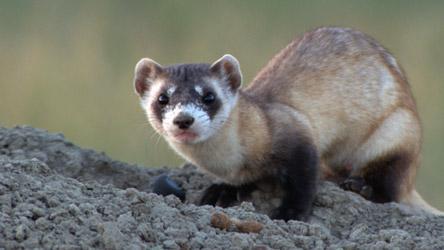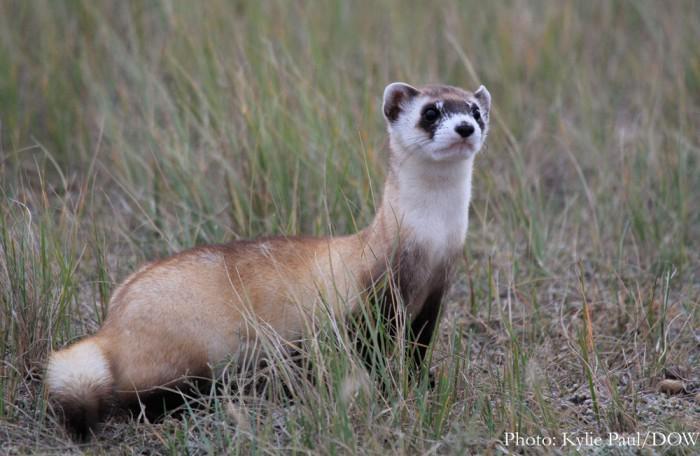The first image is the image on the left, the second image is the image on the right. For the images displayed, is the sentence "There are exactly two ferrets." factually correct? Answer yes or no. Yes. The first image is the image on the left, the second image is the image on the right. For the images displayed, is the sentence "The left image contains no more than one ferret." factually correct? Answer yes or no. Yes. 